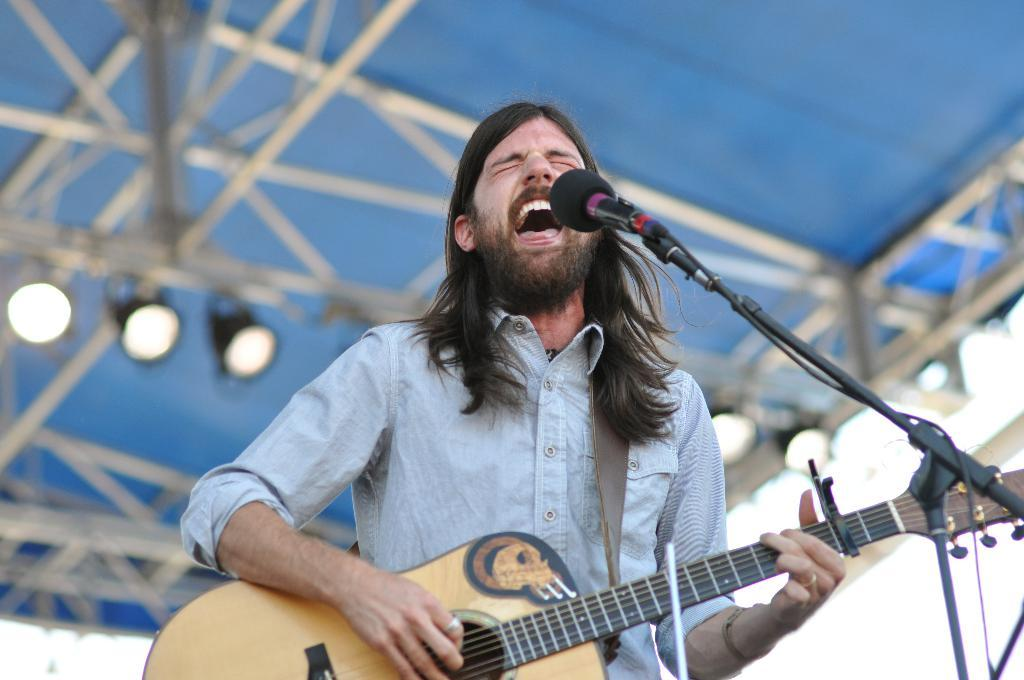What is the main subject of the image? The main subject of the image is a man. Can you describe the man's appearance? The man has long hair. What is the man doing in the image? The man is singing on a mic and playing a guitar. Where is the man performing? The man is performing on a stage. What other objects can be seen in the image? There are poles and roof lights in the image. What type of seed is the man planting on the stage? There is no seed present in the image, and the man is not planting anything; he is singing and playing a guitar. How much income does the man earn from performing in the image? There is no information about the man's income in the image, as it only shows him performing on stage. 